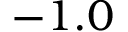<formula> <loc_0><loc_0><loc_500><loc_500>- 1 . 0</formula> 